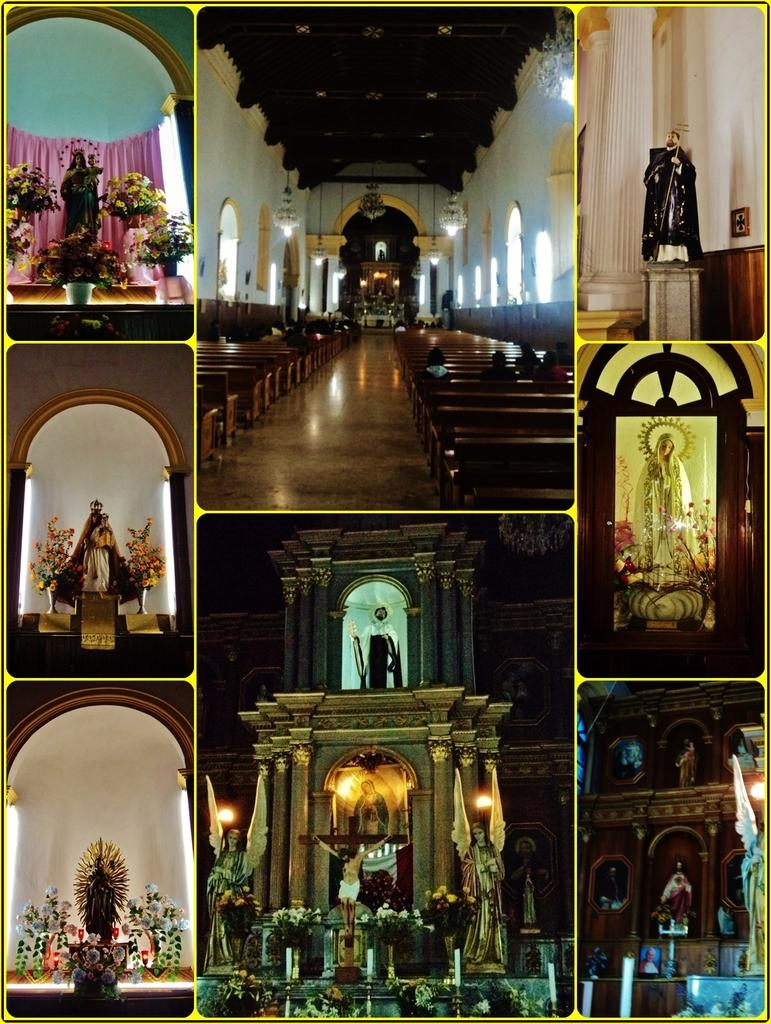What type of artwork is featured in the image? The image contains a collage. Can you describe any specific objects or structures in the collage? Yes, there is a statue, flower pots, a building with stone pillars, benches, and candles in the image. What type of material might be used to create the curtain in the image? The curtain in the image might be made of fabric or a similar material. What type of garden can be seen in the image? There is no garden present in the image; it features a collage with various objects and structures. Can you describe the belief system of the statue in the image? There is no indication of a belief system associated with the statue in the image, as it is a visual representation and not a religious or spiritual figure. 